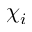<formula> <loc_0><loc_0><loc_500><loc_500>\chi _ { i }</formula> 